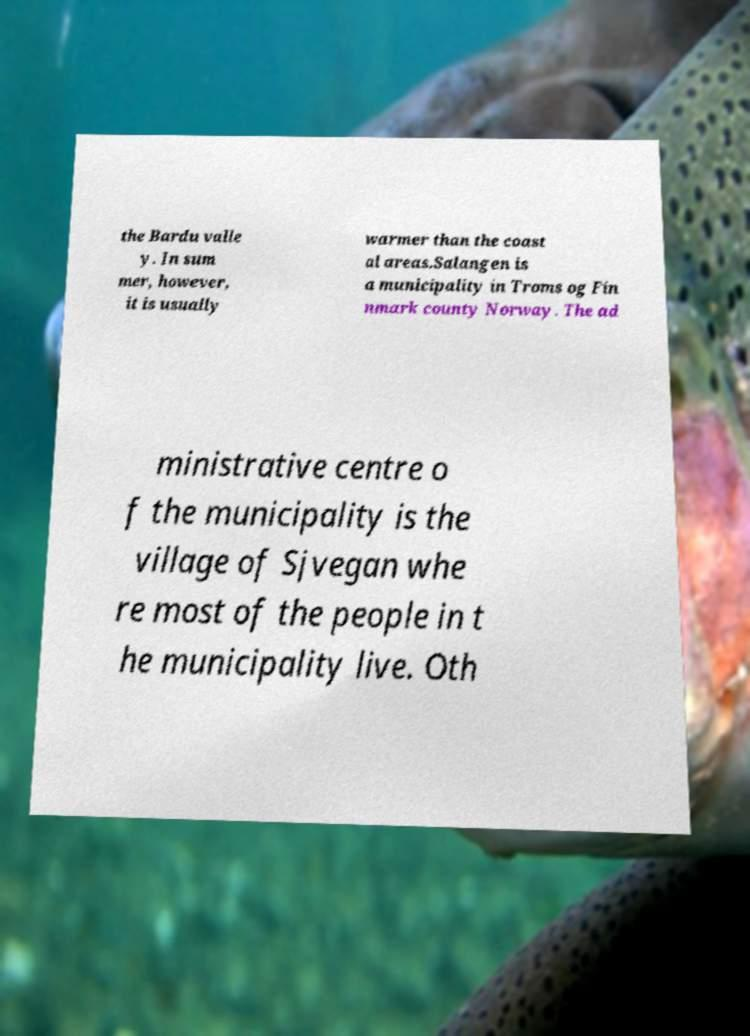There's text embedded in this image that I need extracted. Can you transcribe it verbatim? the Bardu valle y. In sum mer, however, it is usually warmer than the coast al areas.Salangen is a municipality in Troms og Fin nmark county Norway. The ad ministrative centre o f the municipality is the village of Sjvegan whe re most of the people in t he municipality live. Oth 